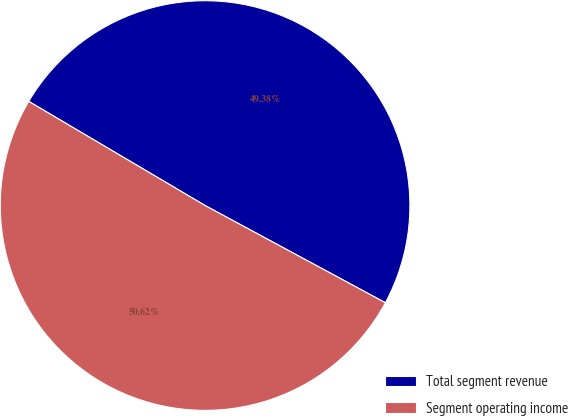<chart> <loc_0><loc_0><loc_500><loc_500><pie_chart><fcel>Total segment revenue<fcel>Segment operating income<nl><fcel>49.38%<fcel>50.62%<nl></chart> 